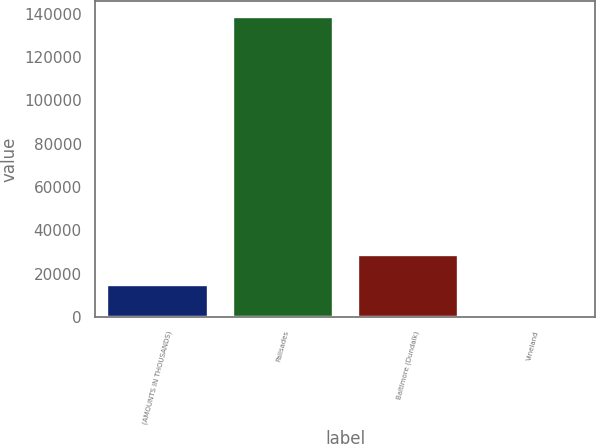Convert chart to OTSL. <chart><loc_0><loc_0><loc_500><loc_500><bar_chart><fcel>(AMOUNTS IN THOUSANDS)<fcel>Palisades<fcel>Baltimore (Dundalk)<fcel>Vineland<nl><fcel>14680.1<fcel>138629<fcel>28452.2<fcel>908<nl></chart> 